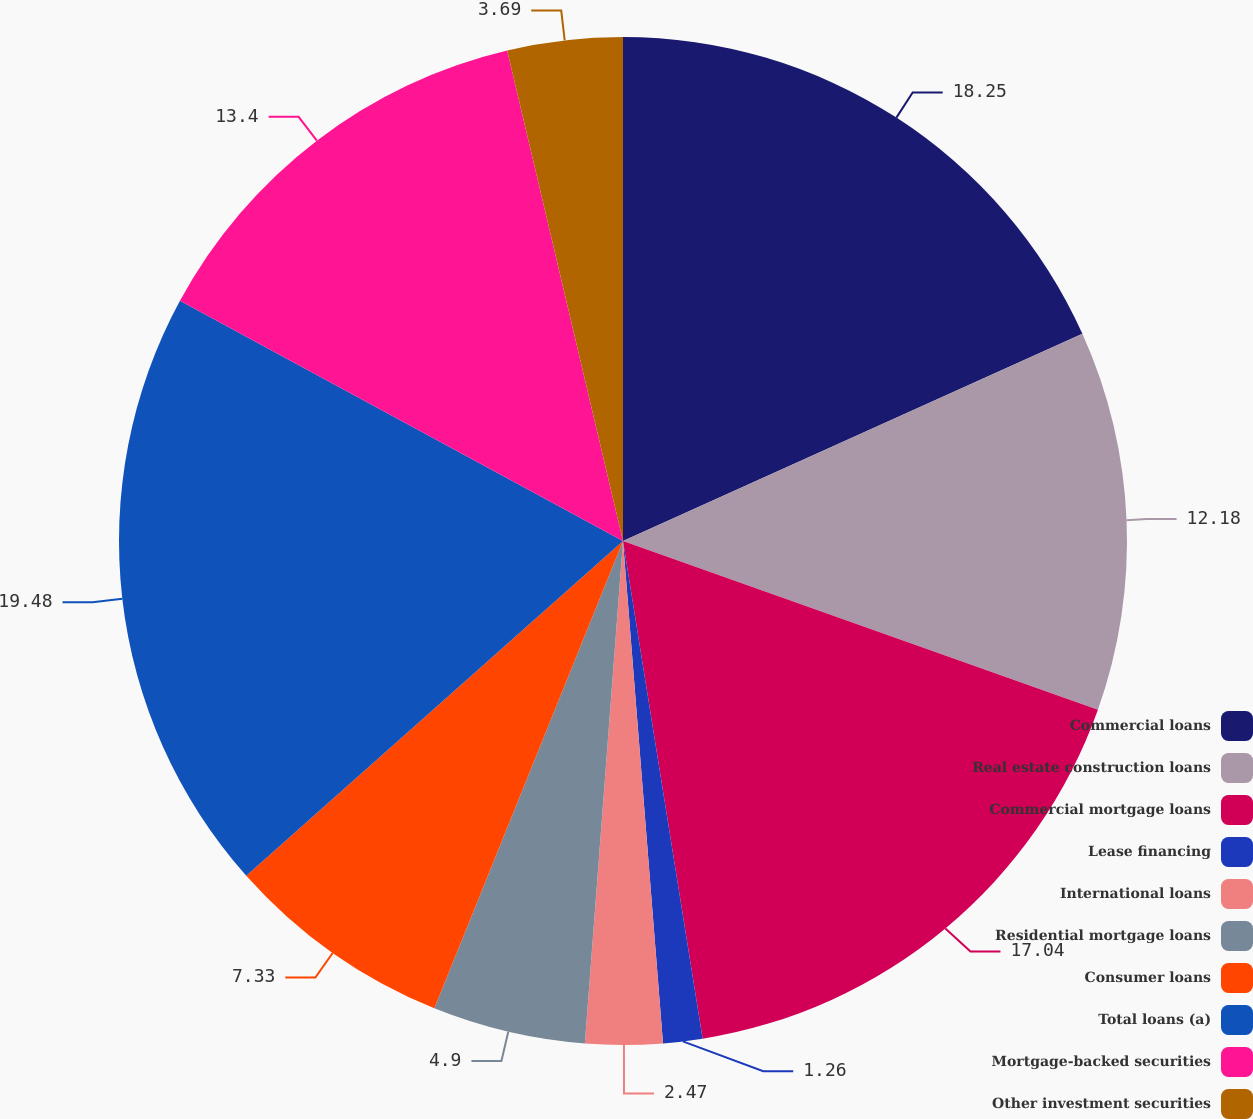Convert chart to OTSL. <chart><loc_0><loc_0><loc_500><loc_500><pie_chart><fcel>Commercial loans<fcel>Real estate construction loans<fcel>Commercial mortgage loans<fcel>Lease financing<fcel>International loans<fcel>Residential mortgage loans<fcel>Consumer loans<fcel>Total loans (a)<fcel>Mortgage-backed securities<fcel>Other investment securities<nl><fcel>18.25%<fcel>12.18%<fcel>17.04%<fcel>1.26%<fcel>2.47%<fcel>4.9%<fcel>7.33%<fcel>19.47%<fcel>13.4%<fcel>3.69%<nl></chart> 